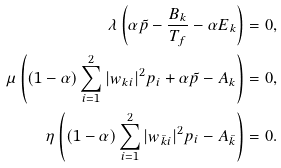Convert formula to latex. <formula><loc_0><loc_0><loc_500><loc_500>\lambda \left ( \alpha \tilde { p } - \frac { B _ { k } } { T _ { f } } - \alpha E _ { k } \right ) & = 0 , \\ \mu \left ( ( 1 - \alpha ) \sum _ { i = 1 } ^ { 2 } | w _ { k i } | ^ { 2 } p _ { i } + \alpha \tilde { p } - A _ { k } \right ) & = 0 , \\ \eta \left ( ( 1 - \alpha ) \sum _ { i = 1 } ^ { 2 } | w _ { \bar { k } i } | ^ { 2 } p _ { i } - A _ { \bar { k } } \right ) & = 0 .</formula> 